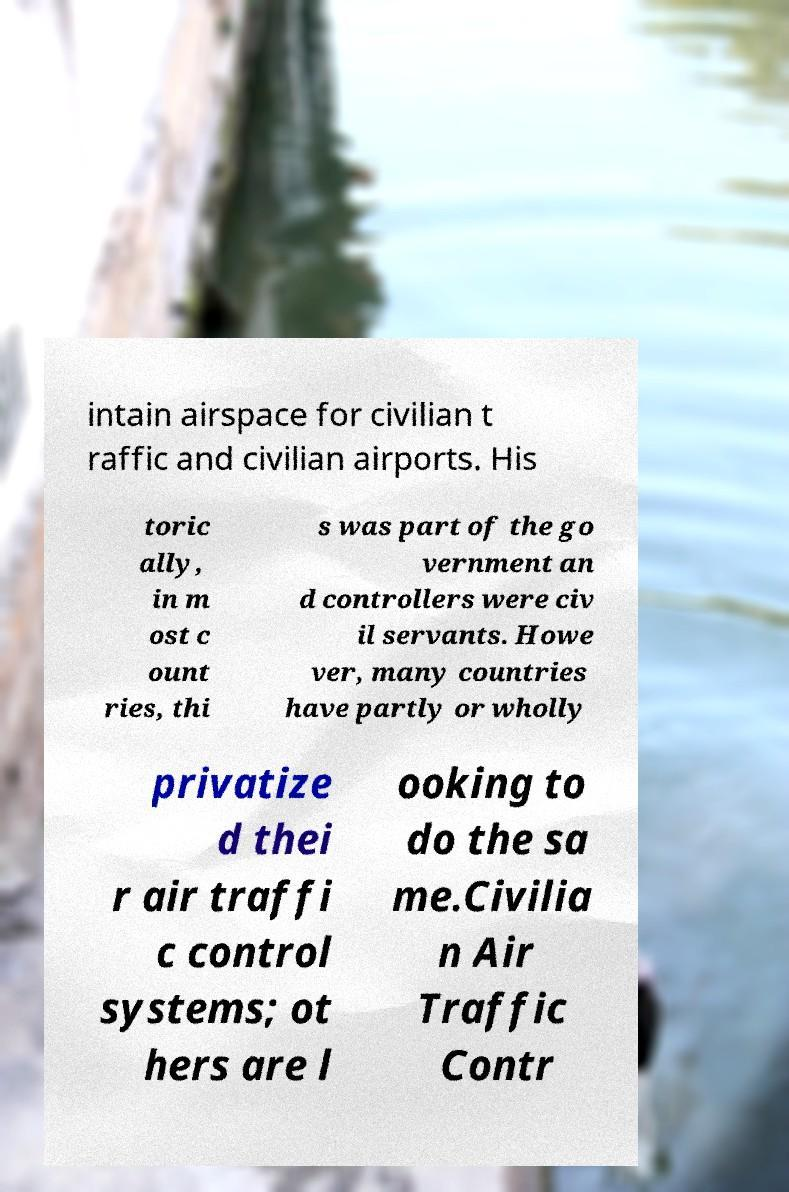What messages or text are displayed in this image? I need them in a readable, typed format. intain airspace for civilian t raffic and civilian airports. His toric ally, in m ost c ount ries, thi s was part of the go vernment an d controllers were civ il servants. Howe ver, many countries have partly or wholly privatize d thei r air traffi c control systems; ot hers are l ooking to do the sa me.Civilia n Air Traffic Contr 